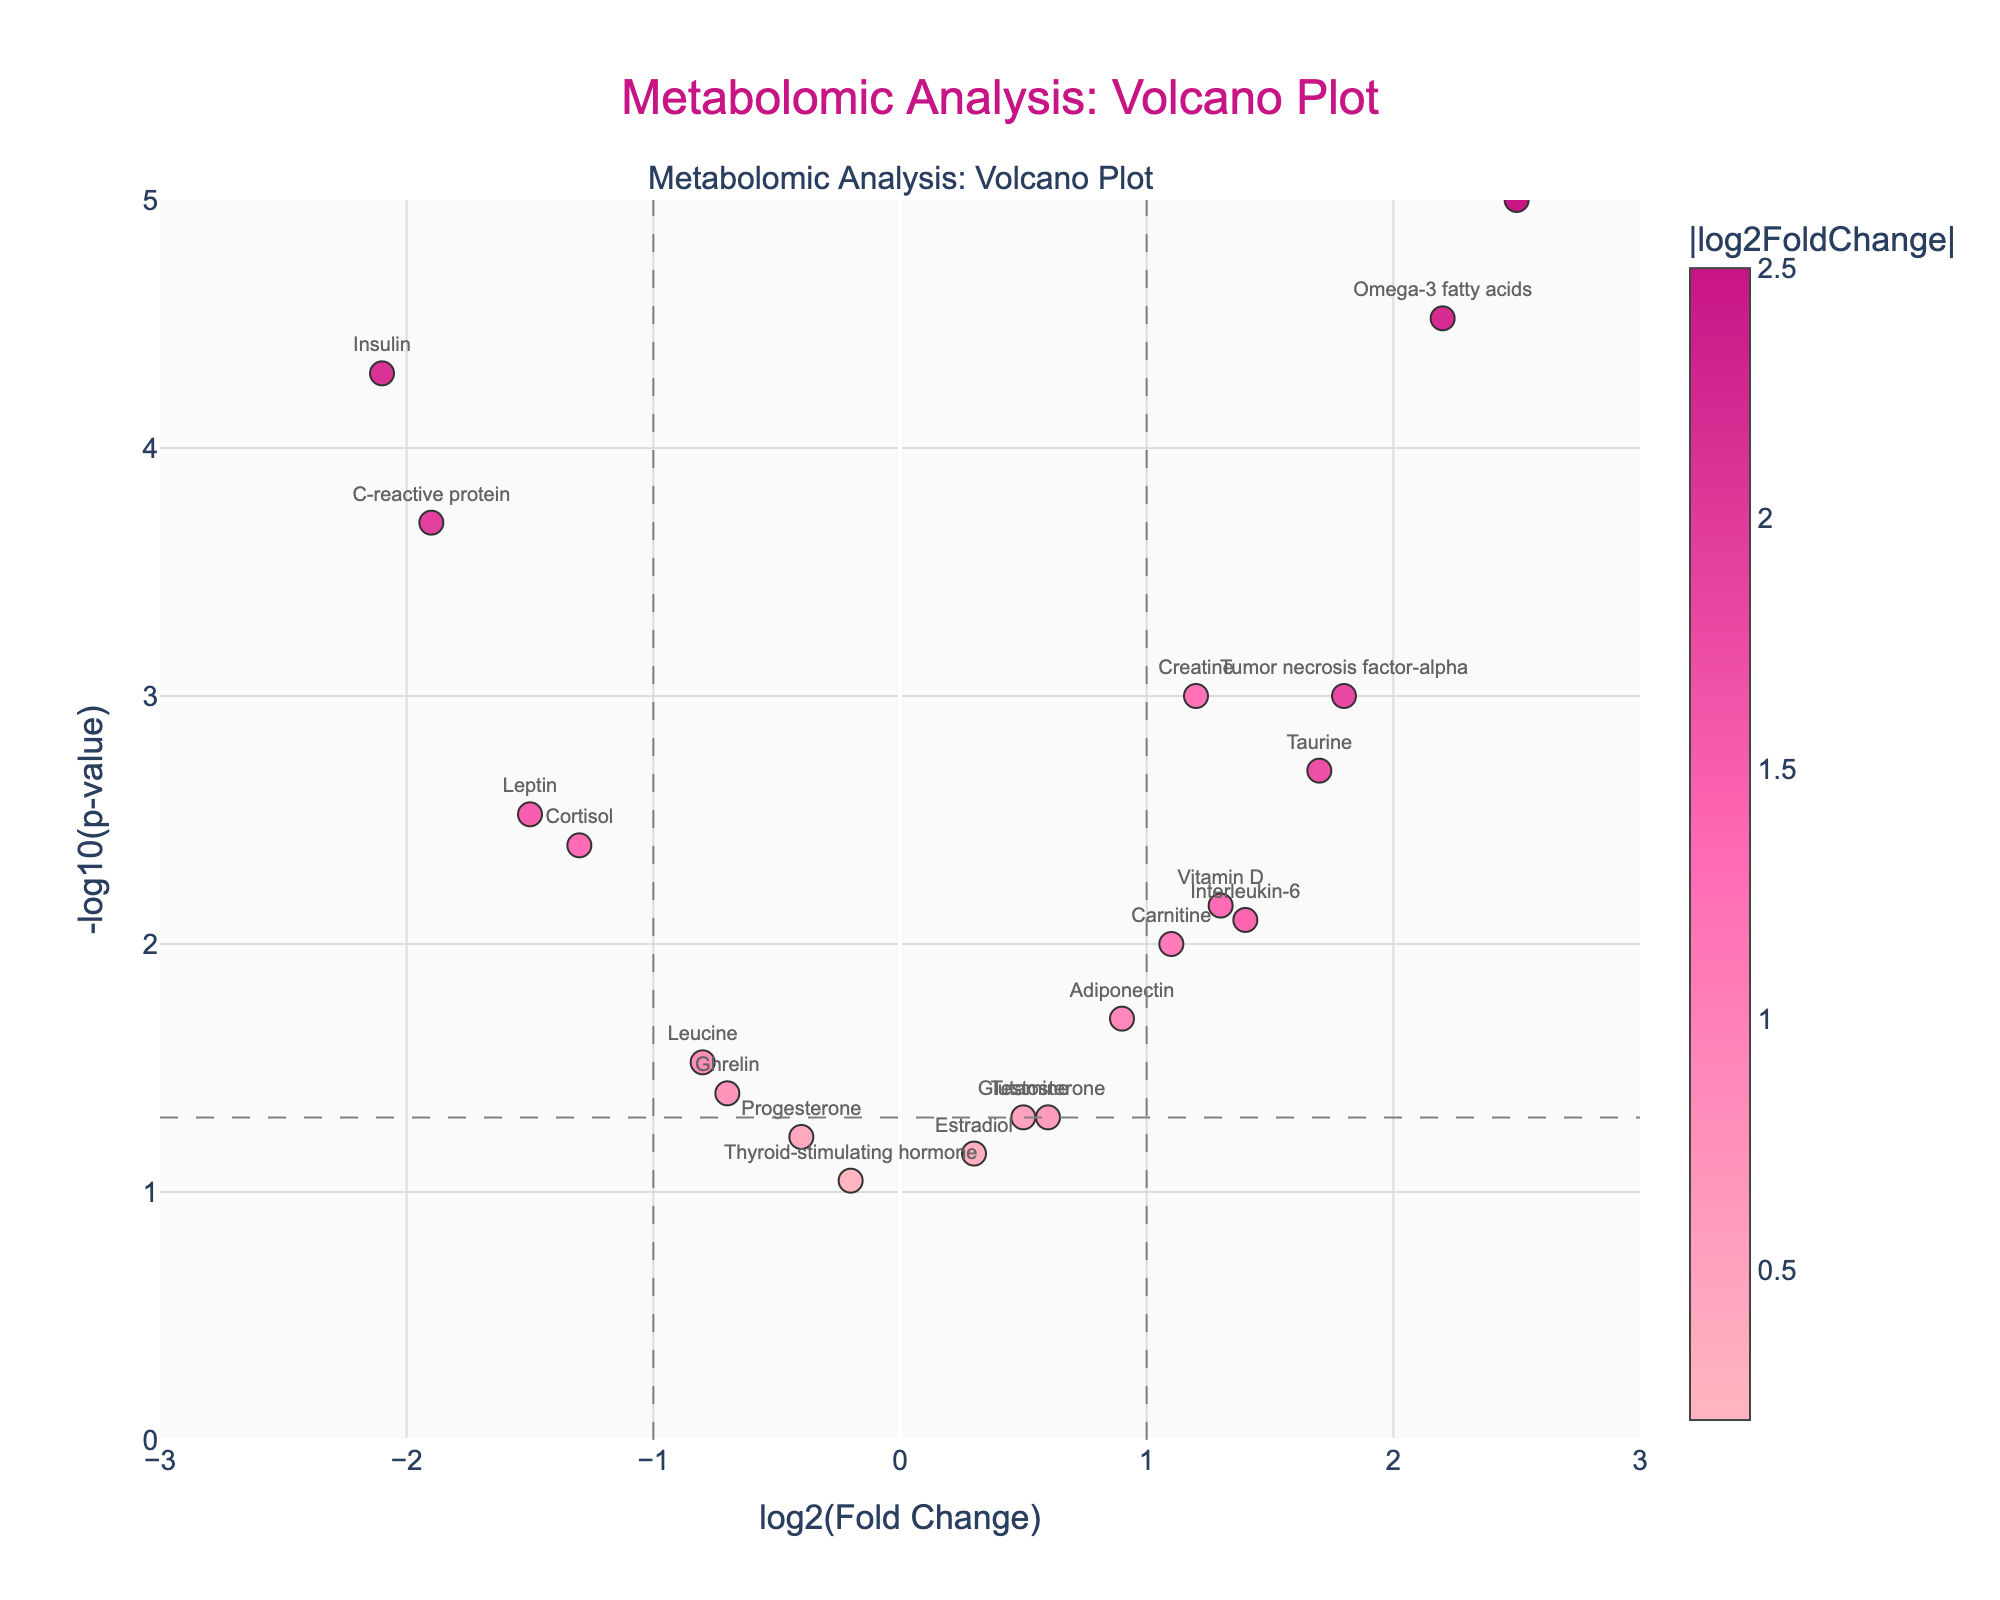What's the title of the plot? The title of a plot is typically displayed at the top center. In this figure, the visible title text is "Metabolomic Analysis: Volcano Plot".
Answer: Metabolomic Analysis: Volcano Plot What does the x-axis represent? The x-axis is the horizontal axis of the plot, and it is labeled as "log2(Fold Change)", indicating the fold change of metabolites on a log base 2 scale.
Answer: log2(Fold Change) Which metabolite has the highest p-value? The p-value is represented on the y-axis as -log10(p-value). The highest p-value corresponds to the smallest -log10(p-value). Among the points, Estradiol has the smallest y-value (just above 0), indicating the highest p-value.
Answer: Estradiol Which metabolites show a log2FoldChange greater than 1? Metabolites with a log2FoldChange greater than 1 are located to the right of the vertical line at x = 1. These include Beta-hydroxybutyrate, Taurine, Tumor necrosis factor-alpha, and Omega-3 fatty acids.
Answer: Beta-hydroxybutyrate, Taurine, Tumor necrosis factor-alpha, Omega-3 fatty acids Which metabolite is associated with the lowest p-value? The lowest p-value corresponds to the highest -log10(p-value). Beta-hydroxybutyrate has the highest y-value, indicating the lowest p-value.
Answer: Beta-hydroxybutyrate How many metabolites have a -log10(p-value) greater than 3? Metabolites with -log10(p-value) greater than 3 are above the horizontal line at y = 3. Observing the plot, we can see three such points: Beta-hydroxybutyrate, Insulin, and Omega-3 fatty acids.
Answer: 3 Which metabolite has the lowest fold change? The lowest fold change corresponds to the most negative log2FoldChange. Insulin has the most negative x-value, so it has the lowest fold change.
Answer: Insulin Which metabolites are considered statistically significant at a p-value threshold of 0.01? Statistically significant metabolites have -log10(p-value) greater than 2, as -log10(0.01) = 2. These points are vertically above the y-value of 2. They include Creatine, Beta-hydroxybutyrate, Taurine, Cortisol, Insulin, Leptin, Tumor necrosis factor-alpha, C-reactive protein, Vitamin D, and Omega-3 fatty acids.
Answer: Creatine, Beta-hydroxybutyrate, Taurine, Cortisol, Insulin, Leptin, Tumor necrosis factor-alpha, C-reactive protein, Vitamin D, Omega-3 fatty acids 